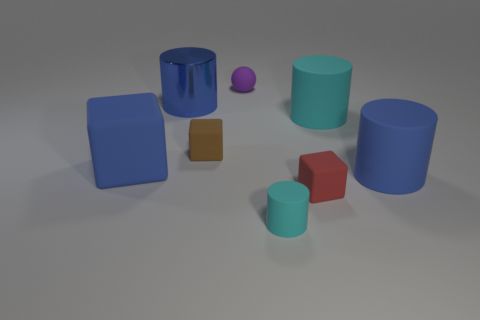Subtract all small cubes. How many cubes are left? 1 Subtract 1 blocks. How many blocks are left? 2 Add 1 green rubber objects. How many objects exist? 9 Subtract all red cubes. How many cubes are left? 2 Subtract all balls. How many objects are left? 7 Subtract all brown cylinders. Subtract all cyan spheres. How many cylinders are left? 4 Subtract all green cubes. How many cyan cylinders are left? 2 Subtract all small brown rubber cubes. Subtract all big cyan matte things. How many objects are left? 6 Add 3 big things. How many big things are left? 7 Add 7 big cylinders. How many big cylinders exist? 10 